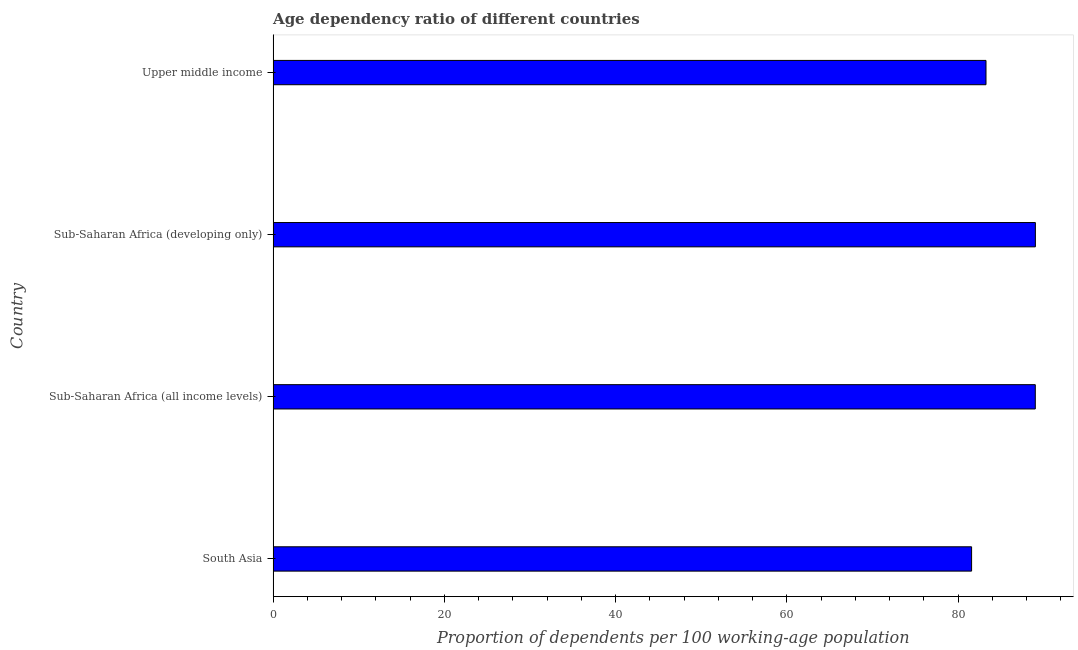Does the graph contain any zero values?
Offer a very short reply. No. Does the graph contain grids?
Offer a terse response. No. What is the title of the graph?
Provide a succinct answer. Age dependency ratio of different countries. What is the label or title of the X-axis?
Ensure brevity in your answer.  Proportion of dependents per 100 working-age population. What is the age dependency ratio in Sub-Saharan Africa (all income levels)?
Your answer should be compact. 89.03. Across all countries, what is the maximum age dependency ratio?
Offer a very short reply. 89.04. Across all countries, what is the minimum age dependency ratio?
Your answer should be very brief. 81.59. In which country was the age dependency ratio maximum?
Your answer should be compact. Sub-Saharan Africa (developing only). What is the sum of the age dependency ratio?
Ensure brevity in your answer.  342.91. What is the difference between the age dependency ratio in South Asia and Sub-Saharan Africa (all income levels)?
Give a very brief answer. -7.44. What is the average age dependency ratio per country?
Your answer should be very brief. 85.73. What is the median age dependency ratio?
Your answer should be compact. 86.15. In how many countries, is the age dependency ratio greater than 72 ?
Provide a succinct answer. 4. What is the ratio of the age dependency ratio in Sub-Saharan Africa (all income levels) to that in Upper middle income?
Provide a succinct answer. 1.07. Is the difference between the age dependency ratio in Sub-Saharan Africa (all income levels) and Sub-Saharan Africa (developing only) greater than the difference between any two countries?
Keep it short and to the point. No. What is the difference between the highest and the second highest age dependency ratio?
Provide a short and direct response. 0.01. Is the sum of the age dependency ratio in Sub-Saharan Africa (all income levels) and Sub-Saharan Africa (developing only) greater than the maximum age dependency ratio across all countries?
Offer a very short reply. Yes. What is the difference between the highest and the lowest age dependency ratio?
Your answer should be compact. 7.45. Are the values on the major ticks of X-axis written in scientific E-notation?
Offer a very short reply. No. What is the Proportion of dependents per 100 working-age population in South Asia?
Ensure brevity in your answer.  81.59. What is the Proportion of dependents per 100 working-age population of Sub-Saharan Africa (all income levels)?
Your answer should be compact. 89.03. What is the Proportion of dependents per 100 working-age population of Sub-Saharan Africa (developing only)?
Your response must be concise. 89.04. What is the Proportion of dependents per 100 working-age population of Upper middle income?
Offer a very short reply. 83.27. What is the difference between the Proportion of dependents per 100 working-age population in South Asia and Sub-Saharan Africa (all income levels)?
Give a very brief answer. -7.44. What is the difference between the Proportion of dependents per 100 working-age population in South Asia and Sub-Saharan Africa (developing only)?
Ensure brevity in your answer.  -7.45. What is the difference between the Proportion of dependents per 100 working-age population in South Asia and Upper middle income?
Your answer should be very brief. -1.68. What is the difference between the Proportion of dependents per 100 working-age population in Sub-Saharan Africa (all income levels) and Sub-Saharan Africa (developing only)?
Offer a very short reply. -0.01. What is the difference between the Proportion of dependents per 100 working-age population in Sub-Saharan Africa (all income levels) and Upper middle income?
Keep it short and to the point. 5.76. What is the difference between the Proportion of dependents per 100 working-age population in Sub-Saharan Africa (developing only) and Upper middle income?
Ensure brevity in your answer.  5.77. What is the ratio of the Proportion of dependents per 100 working-age population in South Asia to that in Sub-Saharan Africa (all income levels)?
Your answer should be compact. 0.92. What is the ratio of the Proportion of dependents per 100 working-age population in South Asia to that in Sub-Saharan Africa (developing only)?
Your answer should be compact. 0.92. What is the ratio of the Proportion of dependents per 100 working-age population in South Asia to that in Upper middle income?
Give a very brief answer. 0.98. What is the ratio of the Proportion of dependents per 100 working-age population in Sub-Saharan Africa (all income levels) to that in Sub-Saharan Africa (developing only)?
Offer a terse response. 1. What is the ratio of the Proportion of dependents per 100 working-age population in Sub-Saharan Africa (all income levels) to that in Upper middle income?
Ensure brevity in your answer.  1.07. What is the ratio of the Proportion of dependents per 100 working-age population in Sub-Saharan Africa (developing only) to that in Upper middle income?
Make the answer very short. 1.07. 